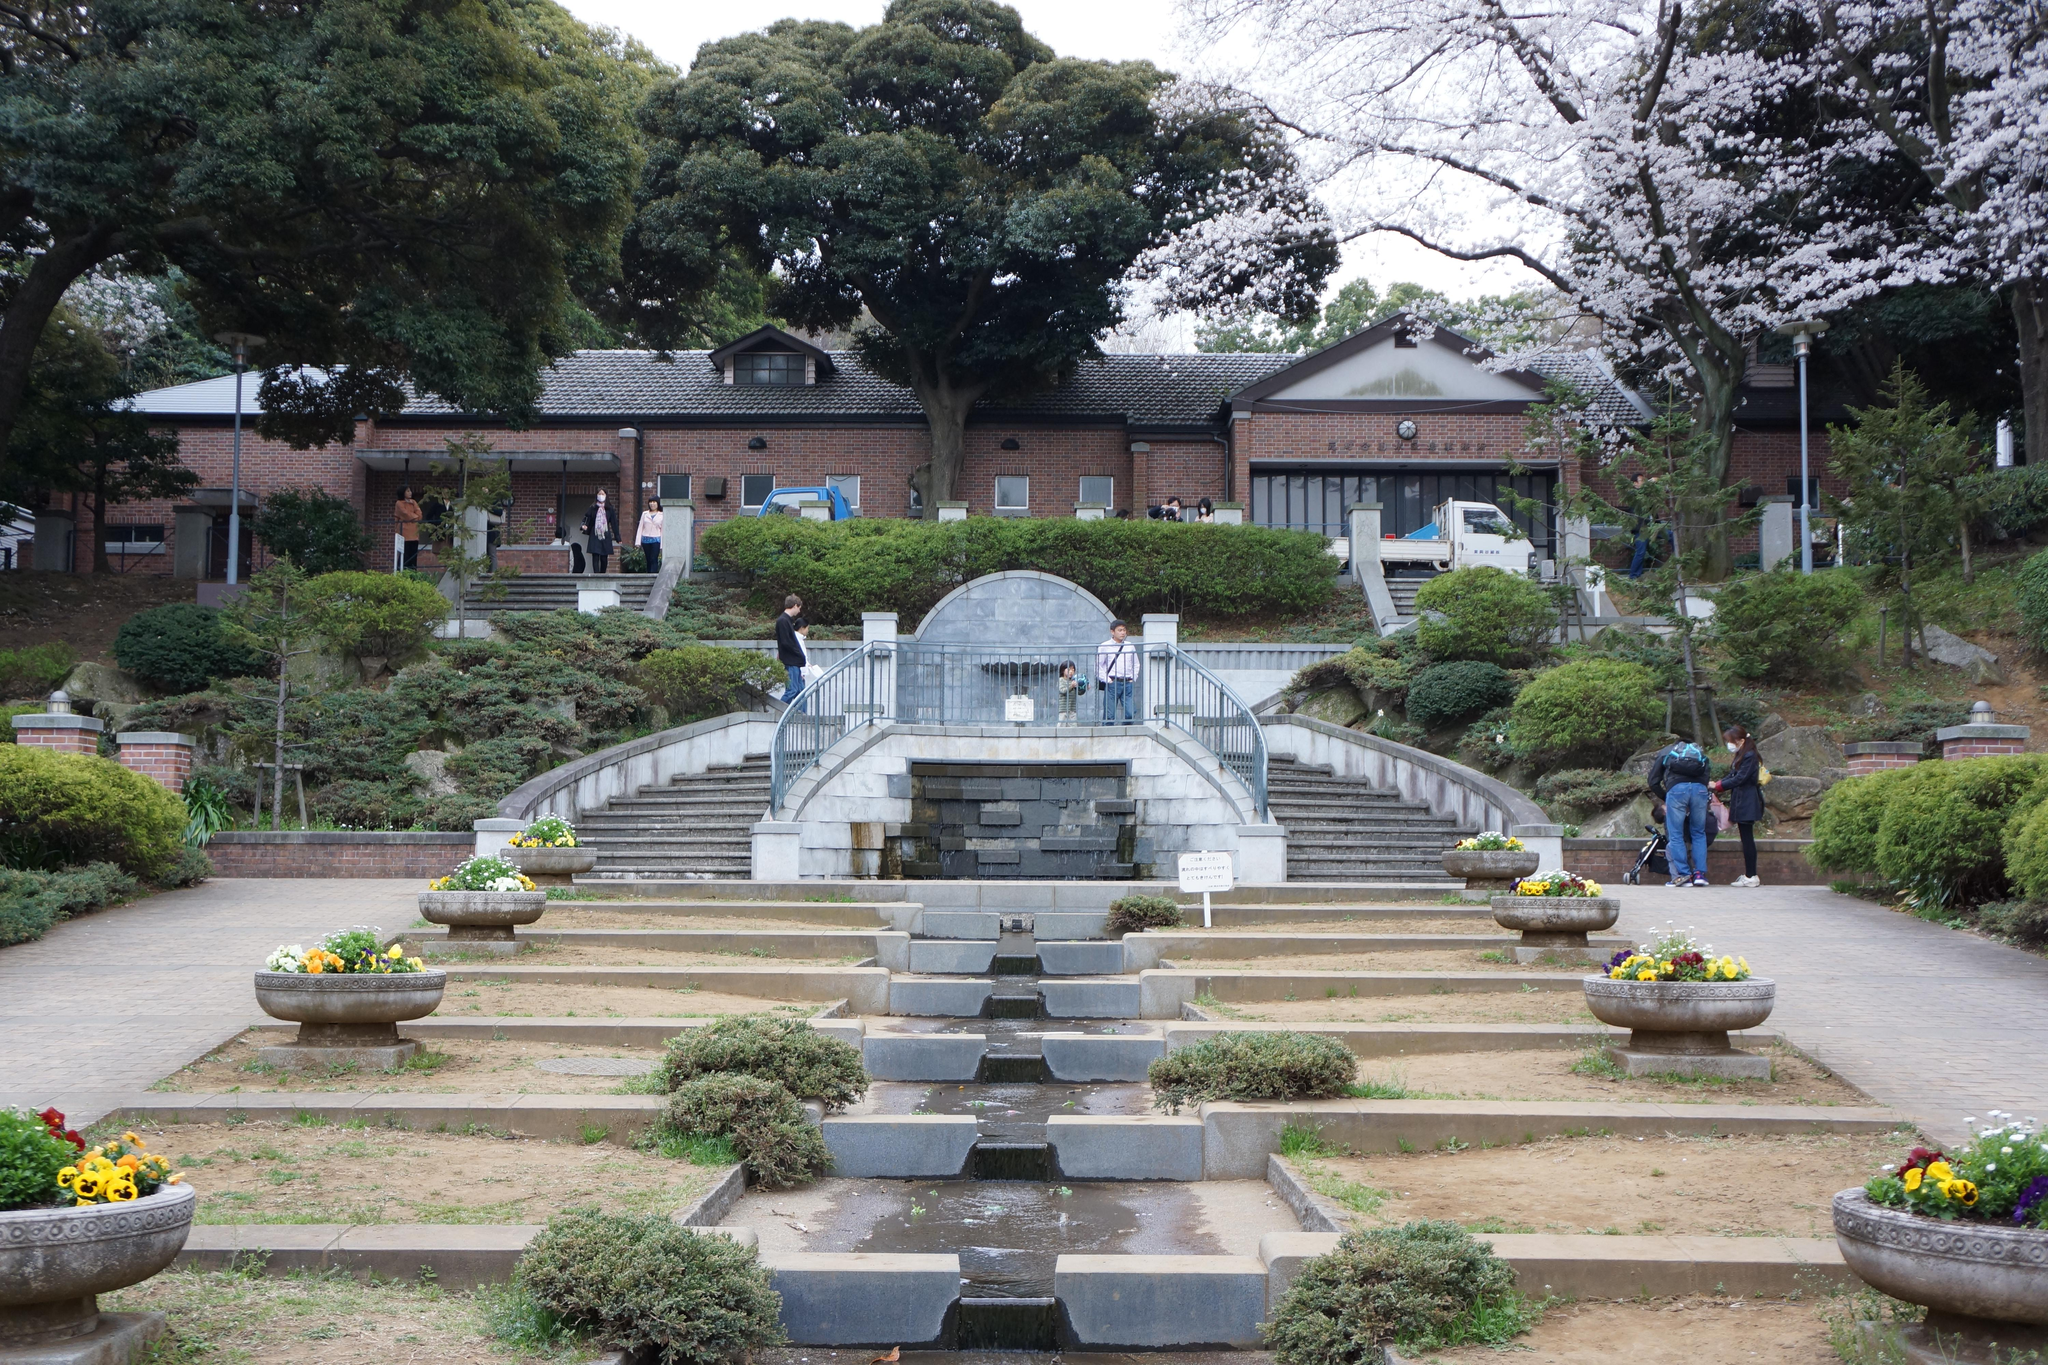What type of structure can be seen in the image? There is a building in the image. What architectural feature is present in the image? There are stairs in the image. What safety feature is included in the image? There is a railing in the image. Are there any living beings in the image? Yes, there are people in the image. What type of vegetation can be seen in the image? There are plants, grass, and trees in the image. What mode of transportation is visible in the image? There is a vehicle in the image. What type of vertical structures are present in the image? There are poles in the image. What part of the natural environment is visible in the image? The sky is visible in the image. What type of cloth is draped over the vehicle in the image? There is no cloth draped over the vehicle in the image. What observation can be made about the temperature in the image? The image does not provide any information about the temperature, so it cannot be determined from the image. 